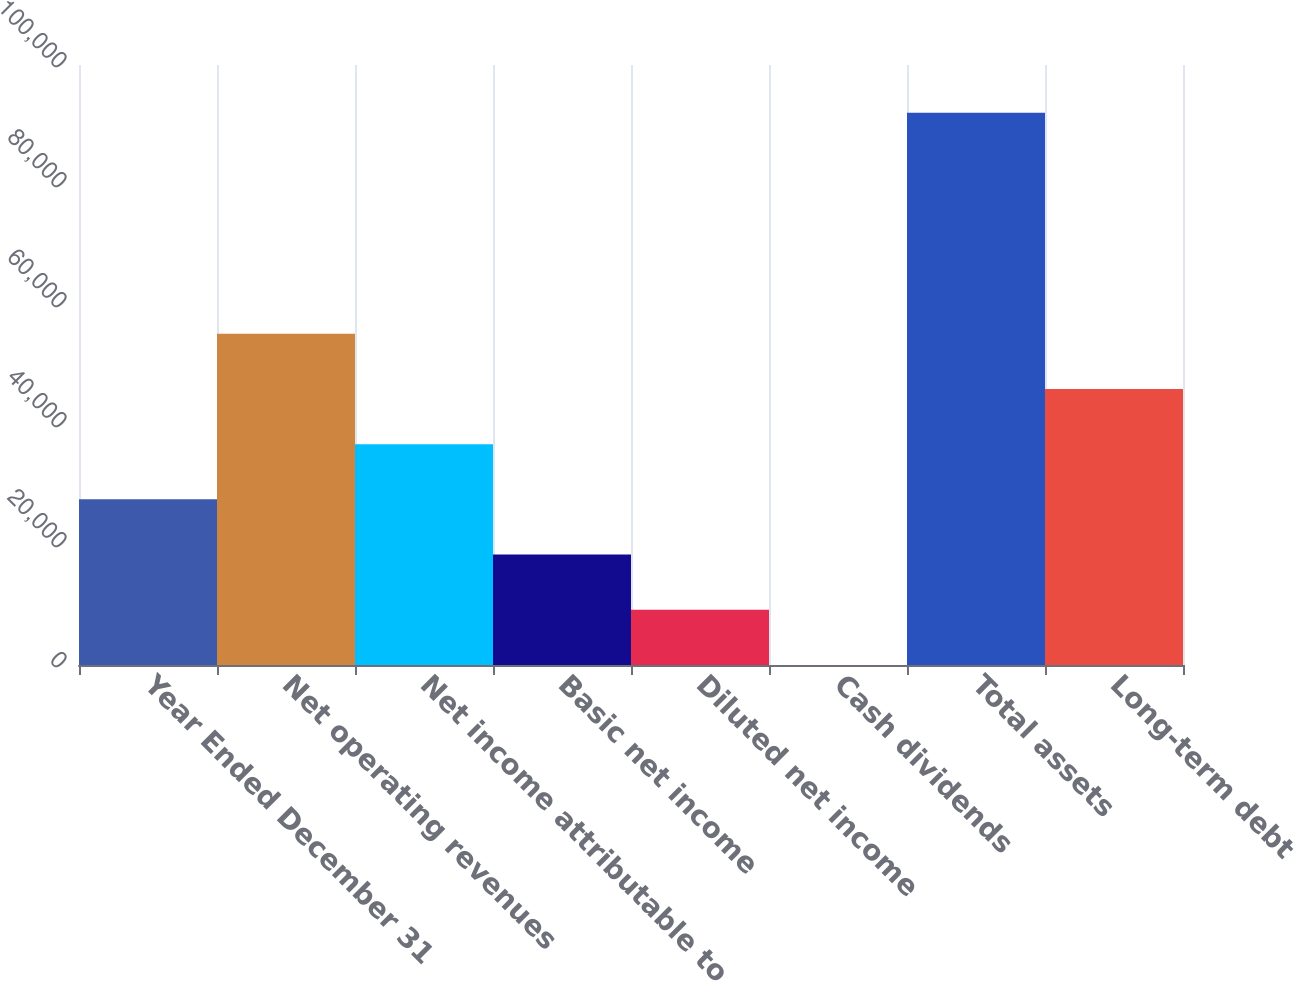Convert chart to OTSL. <chart><loc_0><loc_0><loc_500><loc_500><bar_chart><fcel>Year Ended December 31<fcel>Net operating revenues<fcel>Net income attributable to<fcel>Basic net income<fcel>Diluted net income<fcel>Cash dividends<fcel>Total assets<fcel>Long-term debt<nl><fcel>27607.8<fcel>55214.3<fcel>36809.9<fcel>18405.6<fcel>9203.4<fcel>1.22<fcel>92023<fcel>46012.1<nl></chart> 